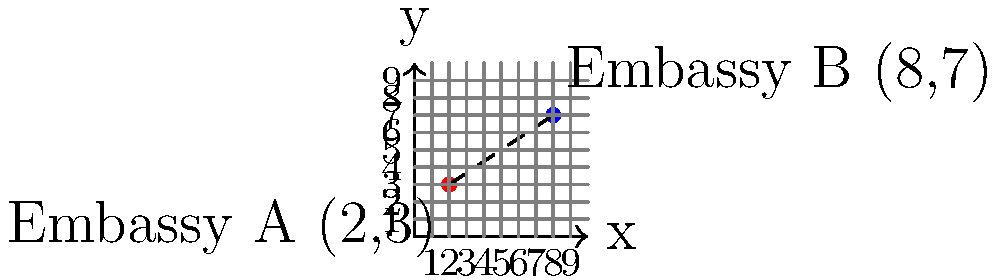On a city map, Embassy A is located at coordinates (2,3) and Embassy B is at (8,7). As an administrative officer supporting diplomatic relations, you need to calculate the shortest distance between these two embassies. Using the distance formula, determine the distance between Embassy A and Embassy B to the nearest tenth of a unit. To solve this problem, we'll use the distance formula derived from the Pythagorean theorem:

$$d = \sqrt{(x_2-x_1)^2 + (y_2-y_1)^2}$$

Where $(x_1,y_1)$ is the coordinate of the first point and $(x_2,y_2)$ is the coordinate of the second point.

Step 1: Identify the coordinates
Embassy A: $(x_1,y_1) = (2,3)$
Embassy B: $(x_2,y_2) = (8,7)$

Step 2: Substitute the values into the formula
$$d = \sqrt{(8-2)^2 + (7-3)^2}$$

Step 3: Simplify inside the parentheses
$$d = \sqrt{6^2 + 4^2}$$

Step 4: Calculate the squares
$$d = \sqrt{36 + 16}$$

Step 5: Add under the square root
$$d = \sqrt{52}$$

Step 6: Simplify the square root
$$d = 2\sqrt{13} \approx 7.2111$$

Step 7: Round to the nearest tenth
$$d \approx 7.2 \text{ units}$$
Answer: 7.2 units 